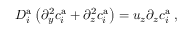Convert formula to latex. <formula><loc_0><loc_0><loc_500><loc_500>D _ { i } ^ { a } \left ( \partial _ { y } ^ { 2 } c _ { i } ^ { a } + \partial _ { z } ^ { 2 } c _ { i } ^ { a } \right ) = u _ { z } \partial _ { z } c _ { i } ^ { a } \, ,</formula> 